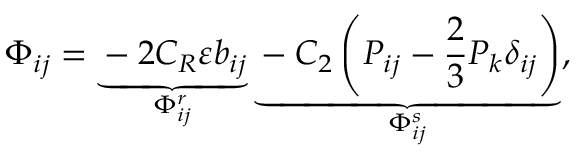<formula> <loc_0><loc_0><loc_500><loc_500>\Phi _ { i j } = \underbrace { - 2 C _ { R } \varepsilon b _ { i j } } _ { \Phi _ { i j } ^ { r } } \underbrace { - C _ { 2 } \left ( P _ { i j } - \frac { 2 } { 3 } P _ { k } \delta _ { i j } \right ) } _ { \Phi _ { i j } ^ { s } } ,</formula> 